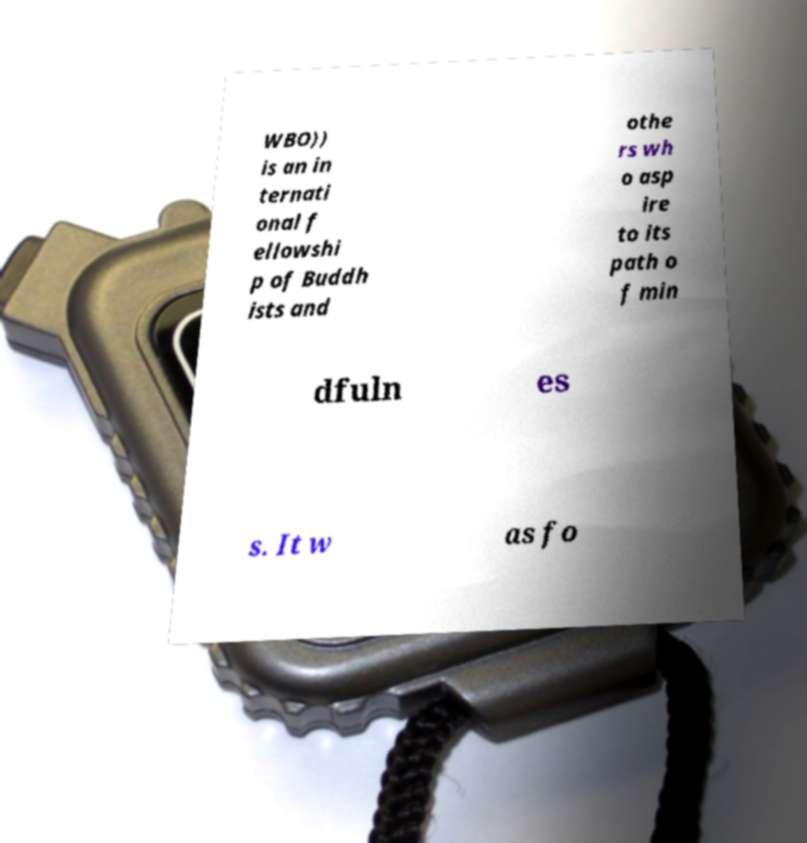For documentation purposes, I need the text within this image transcribed. Could you provide that? WBO)) is an in ternati onal f ellowshi p of Buddh ists and othe rs wh o asp ire to its path o f min dfuln es s. It w as fo 